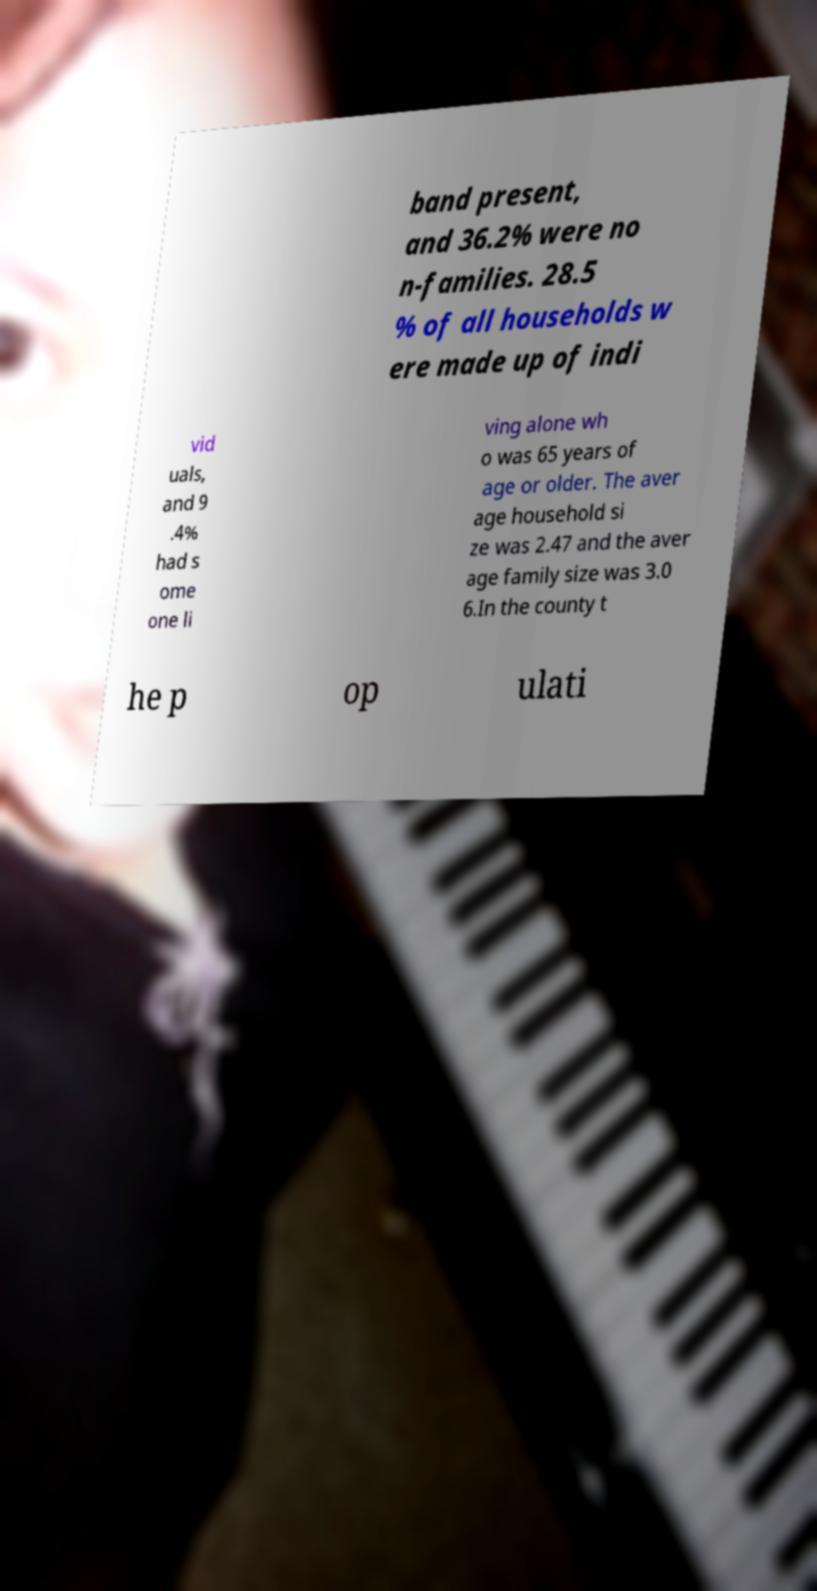Can you read and provide the text displayed in the image?This photo seems to have some interesting text. Can you extract and type it out for me? band present, and 36.2% were no n-families. 28.5 % of all households w ere made up of indi vid uals, and 9 .4% had s ome one li ving alone wh o was 65 years of age or older. The aver age household si ze was 2.47 and the aver age family size was 3.0 6.In the county t he p op ulati 